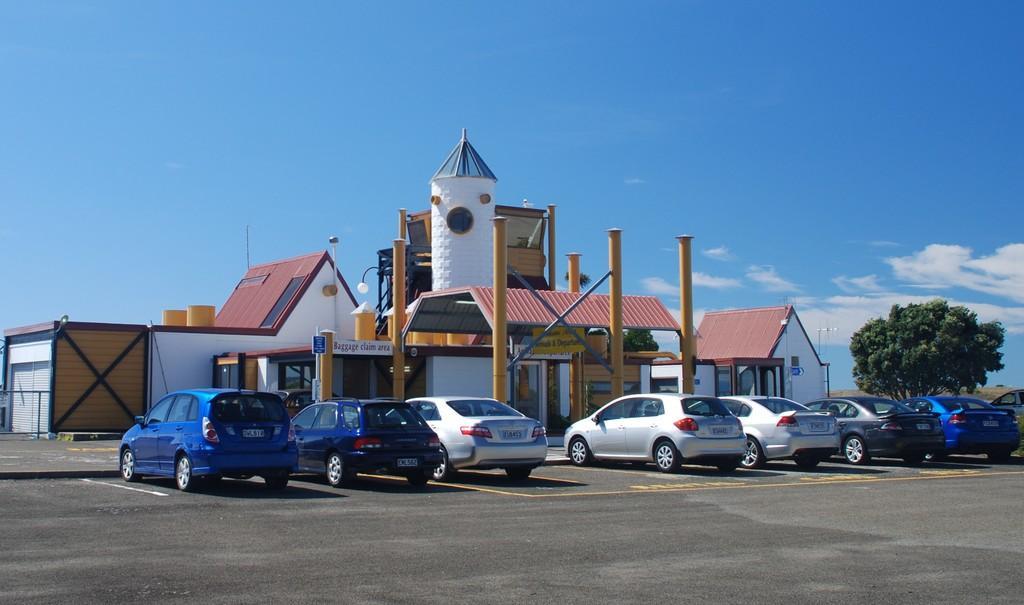In one or two sentences, can you explain what this image depicts? In this image I can see few vehicles on the road, they are in multi color. Background I can see few houses, they are in white and brown color, trees in green color and the sky is in blue and white color. 